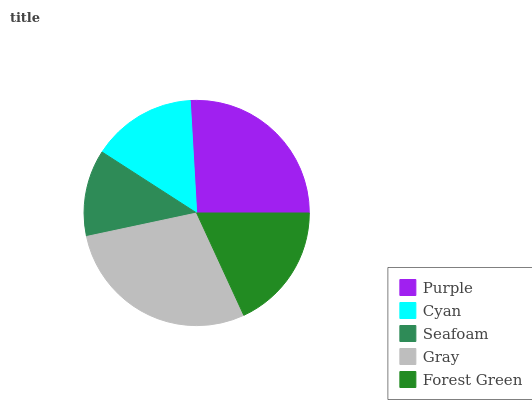Is Seafoam the minimum?
Answer yes or no. Yes. Is Gray the maximum?
Answer yes or no. Yes. Is Cyan the minimum?
Answer yes or no. No. Is Cyan the maximum?
Answer yes or no. No. Is Purple greater than Cyan?
Answer yes or no. Yes. Is Cyan less than Purple?
Answer yes or no. Yes. Is Cyan greater than Purple?
Answer yes or no. No. Is Purple less than Cyan?
Answer yes or no. No. Is Forest Green the high median?
Answer yes or no. Yes. Is Forest Green the low median?
Answer yes or no. Yes. Is Gray the high median?
Answer yes or no. No. Is Cyan the low median?
Answer yes or no. No. 